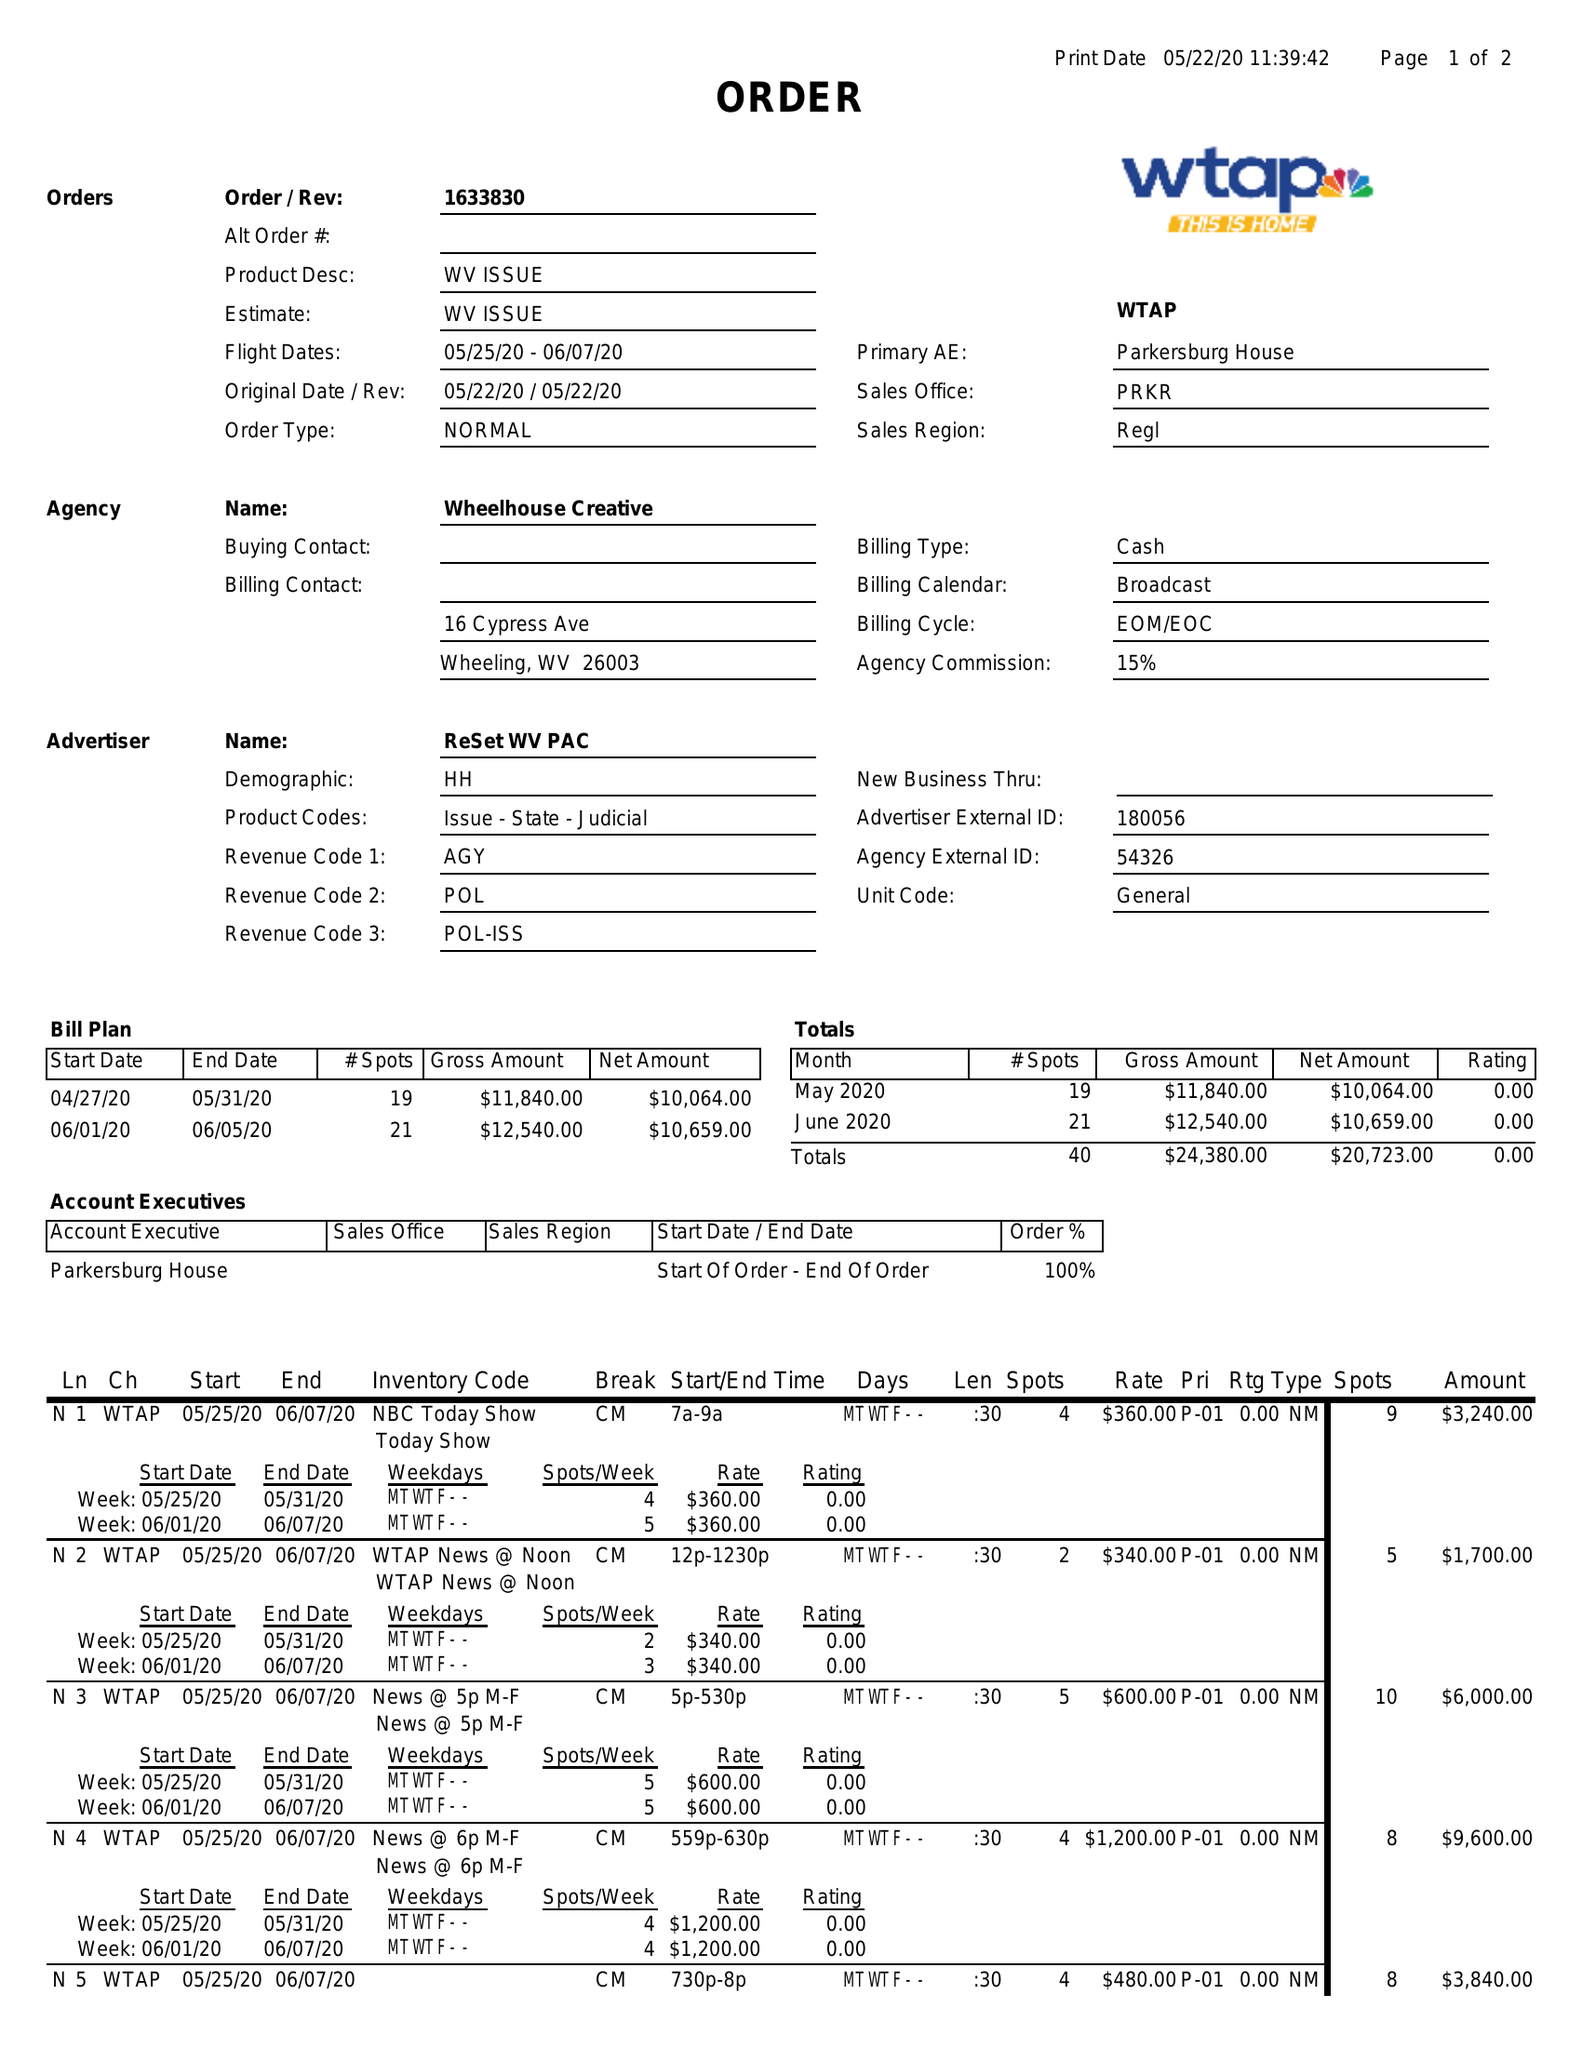What is the value for the flight_from?
Answer the question using a single word or phrase. 05/25/20 